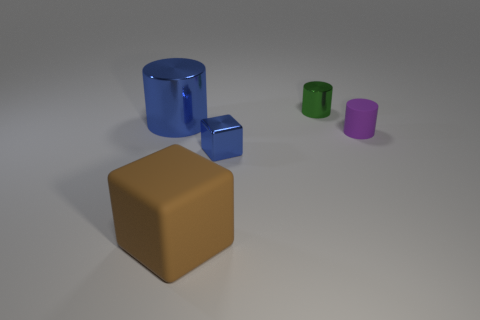Subtract all blue metal cylinders. How many cylinders are left? 2 Add 4 purple rubber cylinders. How many objects exist? 9 Subtract all cylinders. How many objects are left? 2 Subtract all brown cylinders. Subtract all yellow blocks. How many cylinders are left? 3 Subtract all small cyan metallic spheres. Subtract all rubber cylinders. How many objects are left? 4 Add 1 purple cylinders. How many purple cylinders are left? 2 Add 5 large metallic cylinders. How many large metallic cylinders exist? 6 Subtract 0 purple cubes. How many objects are left? 5 